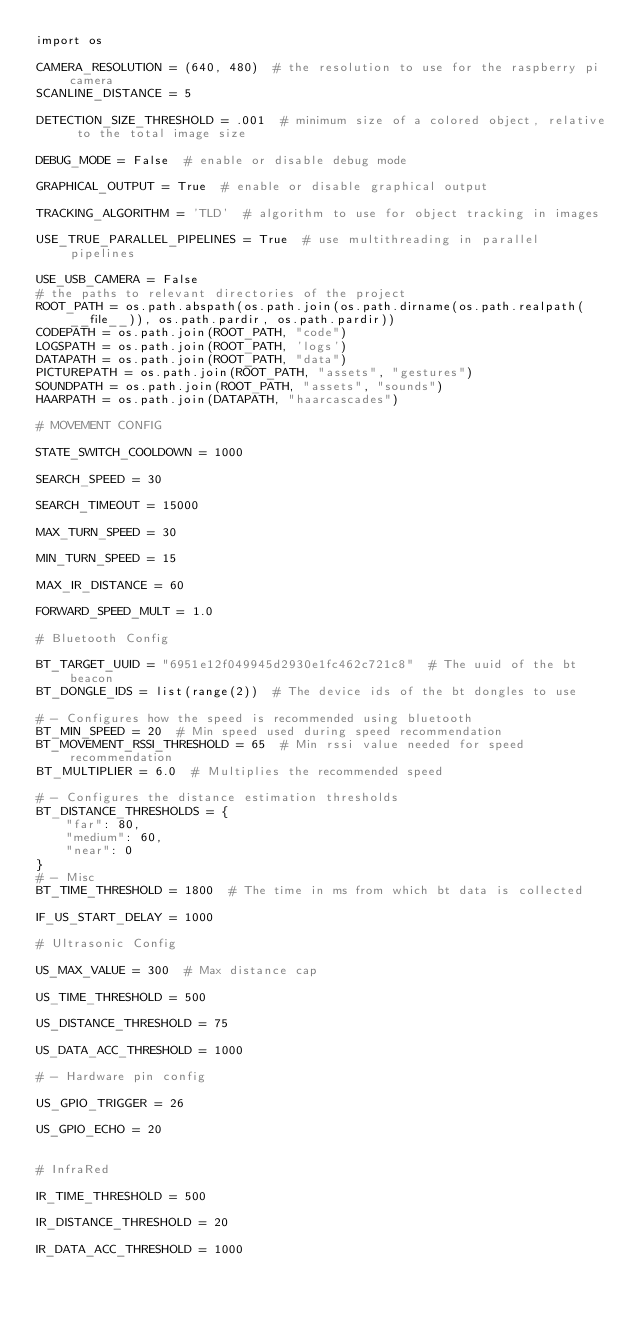<code> <loc_0><loc_0><loc_500><loc_500><_Python_>import os

CAMERA_RESOLUTION = (640, 480)  # the resolution to use for the raspberry pi camera
SCANLINE_DISTANCE = 5

DETECTION_SIZE_THRESHOLD = .001  # minimum size of a colored object, relative to the total image size

DEBUG_MODE = False  # enable or disable debug mode

GRAPHICAL_OUTPUT = True  # enable or disable graphical output

TRACKING_ALGORITHM = 'TLD'  # algorithm to use for object tracking in images

USE_TRUE_PARALLEL_PIPELINES = True  # use multithreading in parallel pipelines

USE_USB_CAMERA = False
# the paths to relevant directories of the project
ROOT_PATH = os.path.abspath(os.path.join(os.path.dirname(os.path.realpath(__file__)), os.path.pardir, os.path.pardir))
CODEPATH = os.path.join(ROOT_PATH, "code")
LOGSPATH = os.path.join(ROOT_PATH, 'logs')
DATAPATH = os.path.join(ROOT_PATH, "data")
PICTUREPATH = os.path.join(ROOT_PATH, "assets", "gestures")
SOUNDPATH = os.path.join(ROOT_PATH, "assets", "sounds")
HAARPATH = os.path.join(DATAPATH, "haarcascades")

# MOVEMENT CONFIG

STATE_SWITCH_COOLDOWN = 1000

SEARCH_SPEED = 30

SEARCH_TIMEOUT = 15000

MAX_TURN_SPEED = 30

MIN_TURN_SPEED = 15

MAX_IR_DISTANCE = 60

FORWARD_SPEED_MULT = 1.0

# Bluetooth Config

BT_TARGET_UUID = "6951e12f049945d2930e1fc462c721c8"  # The uuid of the bt beacon
BT_DONGLE_IDS = list(range(2))  # The device ids of the bt dongles to use

# - Configures how the speed is recommended using bluetooth
BT_MIN_SPEED = 20  # Min speed used during speed recommendation
BT_MOVEMENT_RSSI_THRESHOLD = 65  # Min rssi value needed for speed recommendation
BT_MULTIPLIER = 6.0  # Multiplies the recommended speed

# - Configures the distance estimation thresholds
BT_DISTANCE_THRESHOLDS = {
    "far": 80,
    "medium": 60,
    "near": 0
}
# - Misc
BT_TIME_THRESHOLD = 1800  # The time in ms from which bt data is collected

IF_US_START_DELAY = 1000

# Ultrasonic Config

US_MAX_VALUE = 300  # Max distance cap

US_TIME_THRESHOLD = 500

US_DISTANCE_THRESHOLD = 75

US_DATA_ACC_THRESHOLD = 1000

# - Hardware pin config

US_GPIO_TRIGGER = 26

US_GPIO_ECHO = 20


# InfraRed

IR_TIME_THRESHOLD = 500

IR_DISTANCE_THRESHOLD = 20

IR_DATA_ACC_THRESHOLD = 1000
</code> 